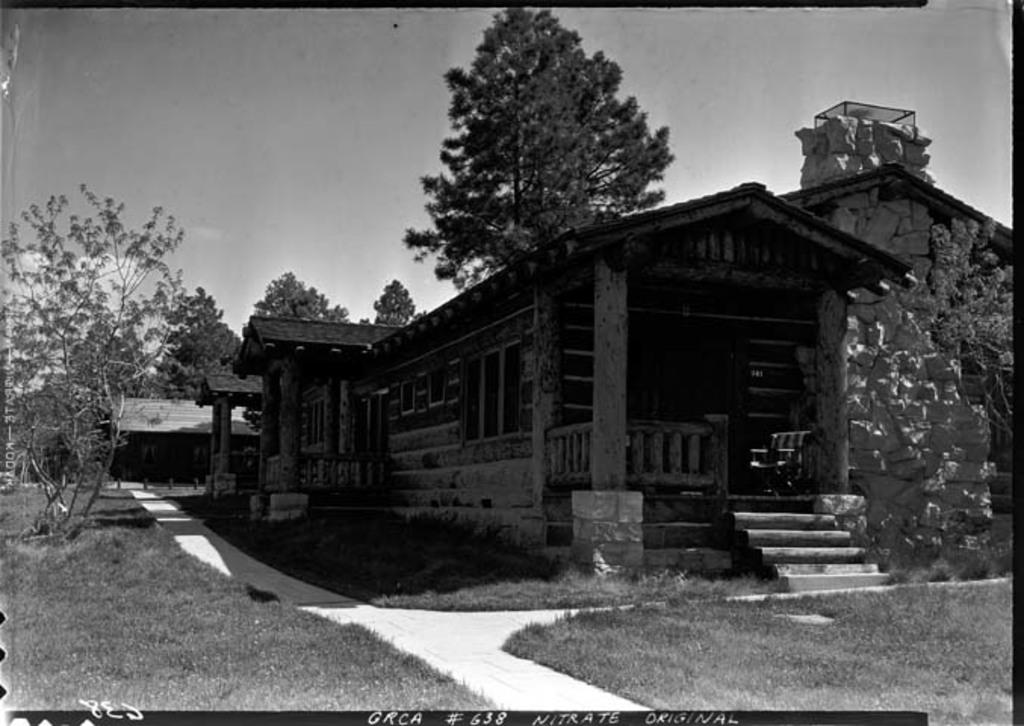What type of image is present in the picture? There is an old photograph in the image. What is depicted in the old photograph? The photograph contains a house and trees. What type of terrain is visible in the photograph? There is grass visible on the surface in the photograph. How much debt does the house in the photograph have? There is no information about the house's debt in the image, as it is an old photograph and not a real-life scenario. 